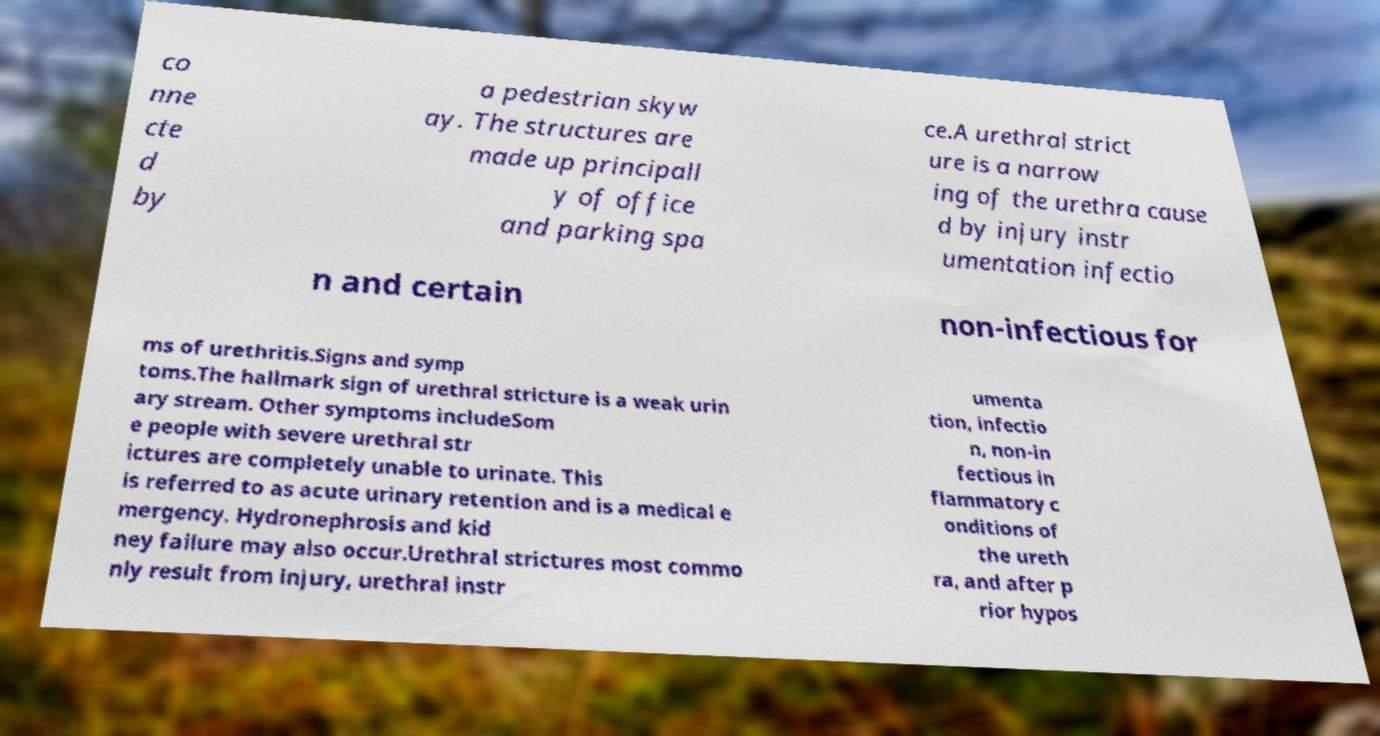Please identify and transcribe the text found in this image. co nne cte d by a pedestrian skyw ay. The structures are made up principall y of office and parking spa ce.A urethral strict ure is a narrow ing of the urethra cause d by injury instr umentation infectio n and certain non-infectious for ms of urethritis.Signs and symp toms.The hallmark sign of urethral stricture is a weak urin ary stream. Other symptoms includeSom e people with severe urethral str ictures are completely unable to urinate. This is referred to as acute urinary retention and is a medical e mergency. Hydronephrosis and kid ney failure may also occur.Urethral strictures most commo nly result from injury, urethral instr umenta tion, infectio n, non-in fectious in flammatory c onditions of the ureth ra, and after p rior hypos 